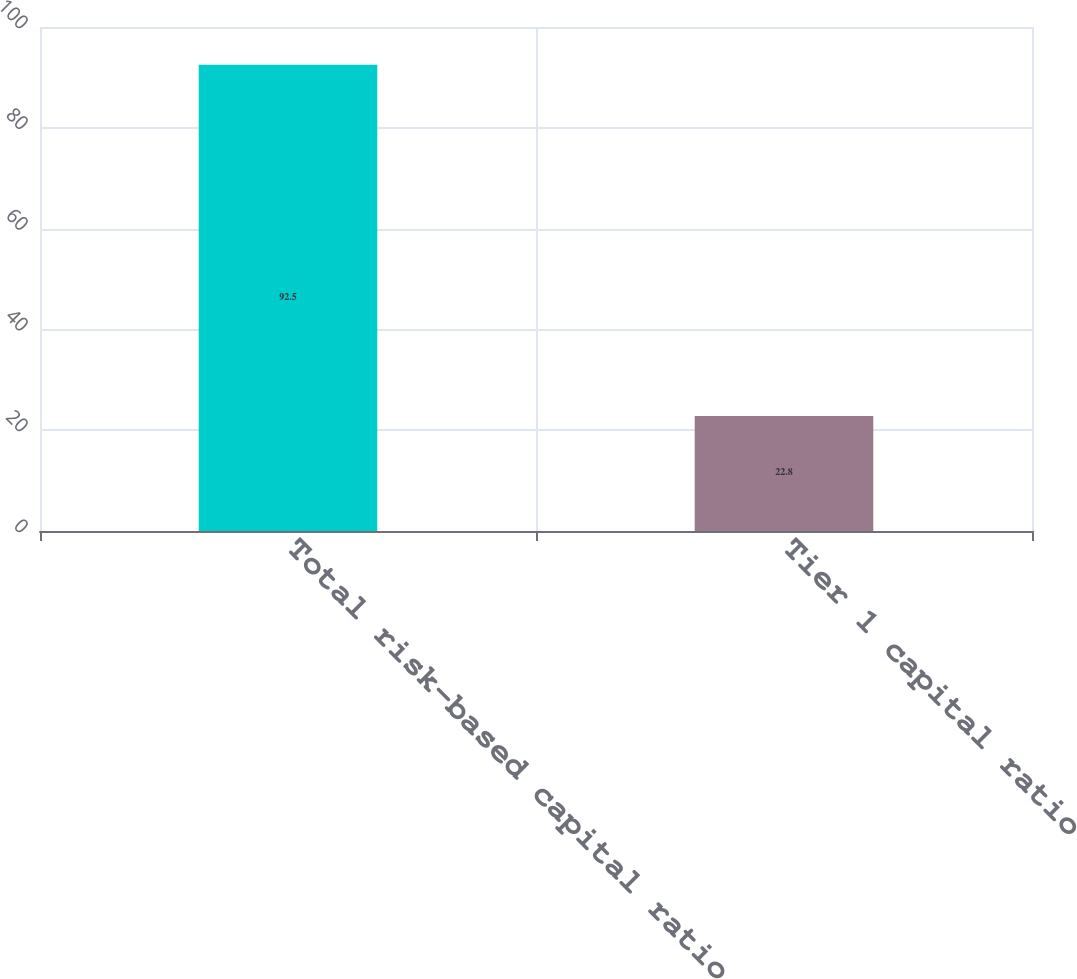Convert chart. <chart><loc_0><loc_0><loc_500><loc_500><bar_chart><fcel>Total risk-based capital ratio<fcel>Tier 1 capital ratio<nl><fcel>92.5<fcel>22.8<nl></chart> 